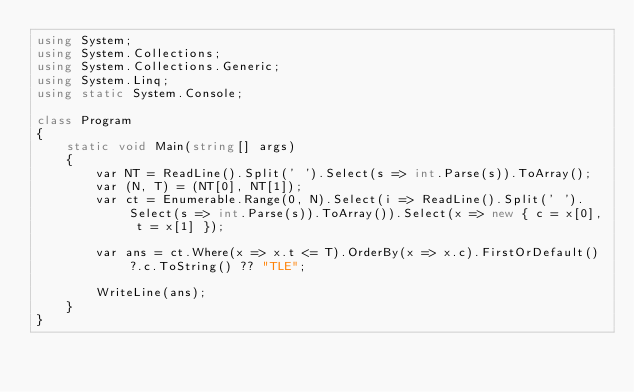Convert code to text. <code><loc_0><loc_0><loc_500><loc_500><_C#_>using System;
using System.Collections;
using System.Collections.Generic;
using System.Linq;
using static System.Console;

class Program
{
    static void Main(string[] args)
    {
        var NT = ReadLine().Split(' ').Select(s => int.Parse(s)).ToArray();
        var (N, T) = (NT[0], NT[1]);
        var ct = Enumerable.Range(0, N).Select(i => ReadLine().Split(' ').Select(s => int.Parse(s)).ToArray()).Select(x => new { c = x[0], t = x[1] });

        var ans = ct.Where(x => x.t <= T).OrderBy(x => x.c).FirstOrDefault()?.c.ToString() ?? "TLE";

        WriteLine(ans);
    }
}
</code> 